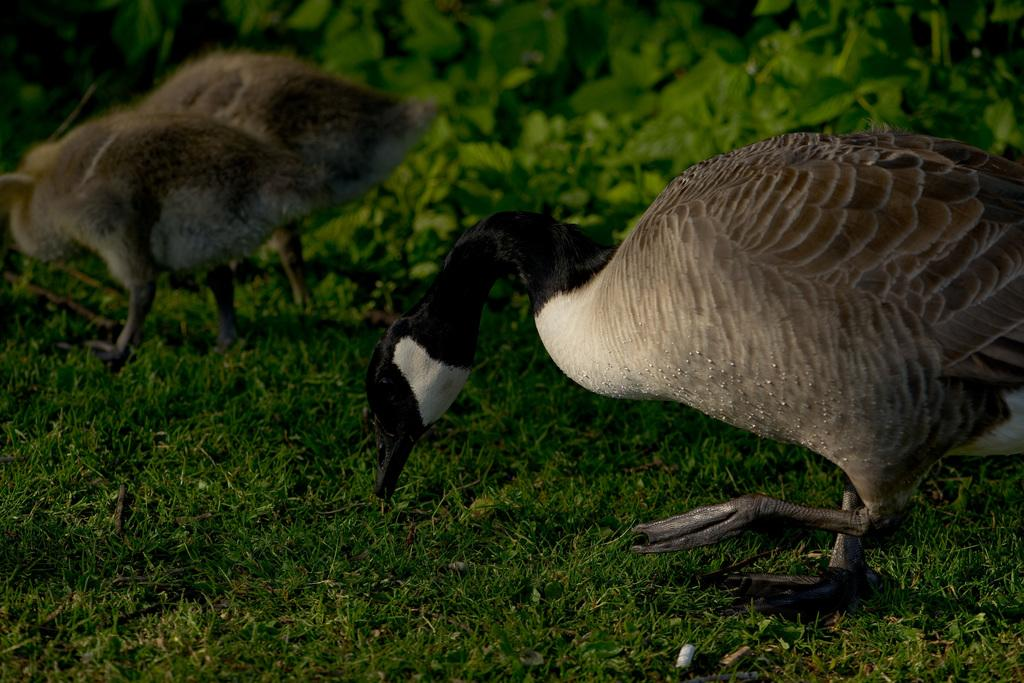What type of animals can be seen in the image? Birds can be seen in the image. What is the environment in which the birds are situated? The birds are in green grass. What flavor of ice cream do the birds prefer in the image? There is no ice cream present in the image, and therefore no preference for flavor can be determined. 